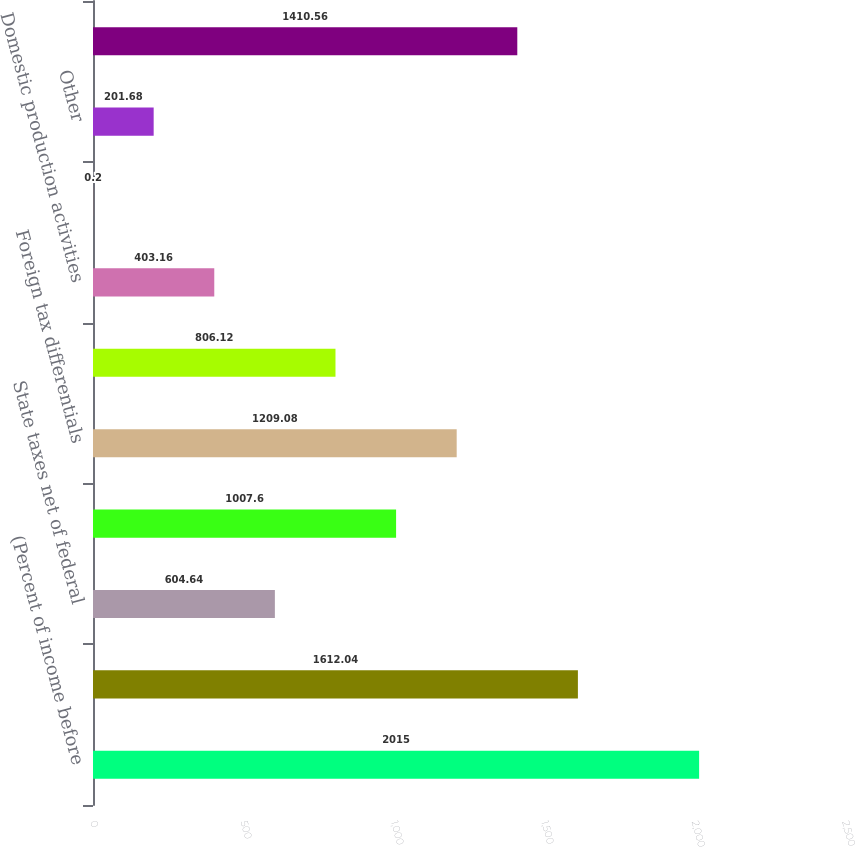Convert chart to OTSL. <chart><loc_0><loc_0><loc_500><loc_500><bar_chart><fcel>(Percent of income before<fcel>US federal statutory tax rate<fcel>State taxes net of federal<fcel>Income from equity affiliates<fcel>Foreign tax differentials<fcel>US taxes on foreign earnings<fcel>Domestic production activities<fcel>Business separation costs<fcel>Other<fcel>Effective Tax Rate<nl><fcel>2015<fcel>1612.04<fcel>604.64<fcel>1007.6<fcel>1209.08<fcel>806.12<fcel>403.16<fcel>0.2<fcel>201.68<fcel>1410.56<nl></chart> 